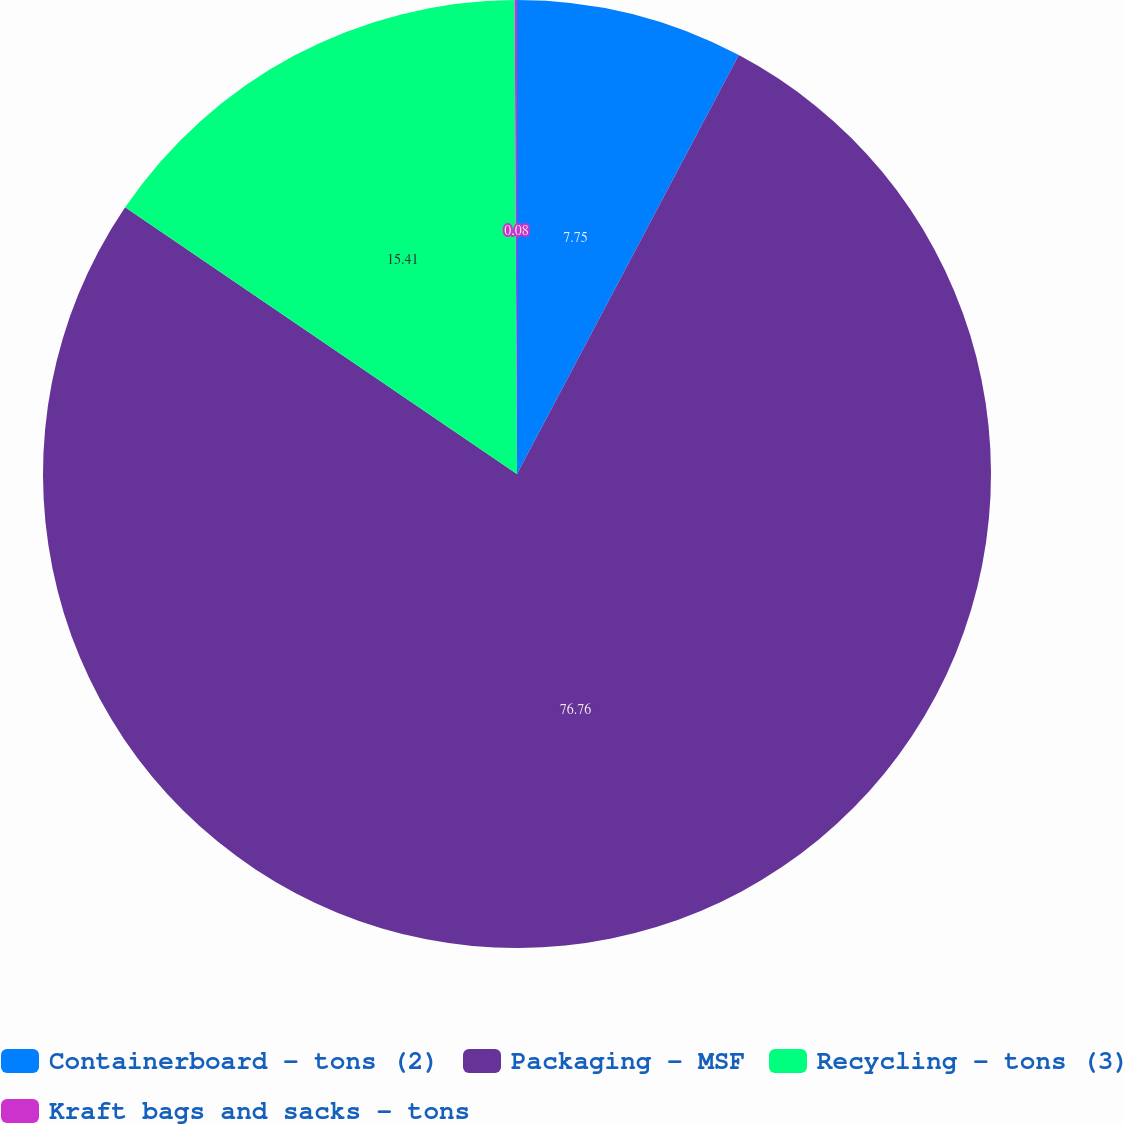<chart> <loc_0><loc_0><loc_500><loc_500><pie_chart><fcel>Containerboard - tons (2)<fcel>Packaging - MSF<fcel>Recycling - tons (3)<fcel>Kraft bags and sacks - tons<nl><fcel>7.75%<fcel>76.76%<fcel>15.41%<fcel>0.08%<nl></chart> 